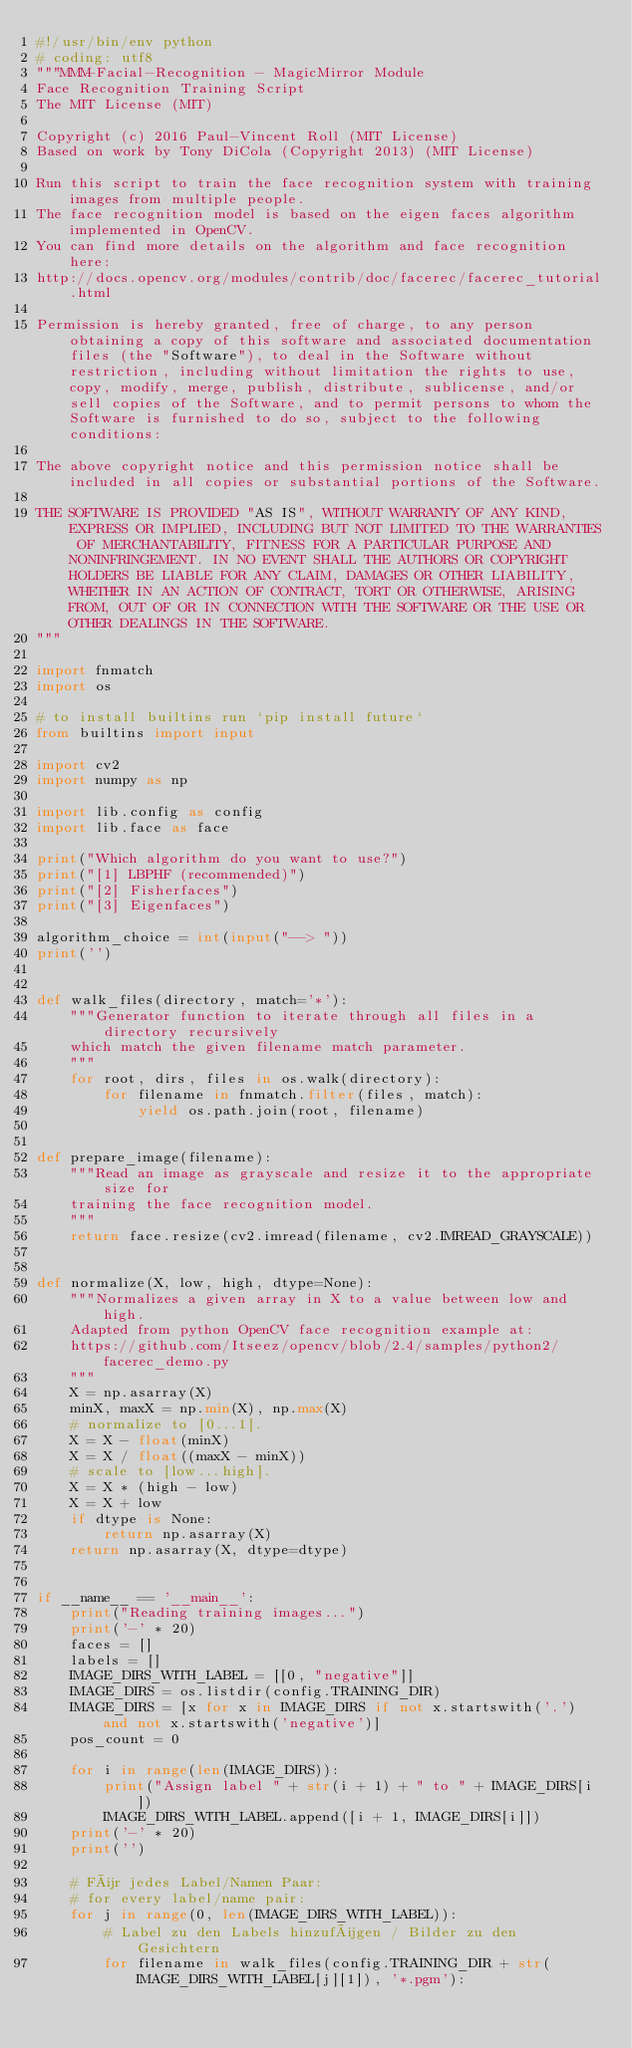Convert code to text. <code><loc_0><loc_0><loc_500><loc_500><_Python_>#!/usr/bin/env python
# coding: utf8
"""MMM-Facial-Recognition - MagicMirror Module
Face Recognition Training Script
The MIT License (MIT)

Copyright (c) 2016 Paul-Vincent Roll (MIT License)
Based on work by Tony DiCola (Copyright 2013) (MIT License)

Run this script to train the face recognition system with training images from multiple people.
The face recognition model is based on the eigen faces algorithm implemented in OpenCV.
You can find more details on the algorithm and face recognition here:
http://docs.opencv.org/modules/contrib/doc/facerec/facerec_tutorial.html

Permission is hereby granted, free of charge, to any person obtaining a copy of this software and associated documentation files (the "Software"), to deal in the Software without restriction, including without limitation the rights to use, copy, modify, merge, publish, distribute, sublicense, and/or sell copies of the Software, and to permit persons to whom the Software is furnished to do so, subject to the following conditions:

The above copyright notice and this permission notice shall be included in all copies or substantial portions of the Software.

THE SOFTWARE IS PROVIDED "AS IS", WITHOUT WARRANTY OF ANY KIND, EXPRESS OR IMPLIED, INCLUDING BUT NOT LIMITED TO THE WARRANTIES OF MERCHANTABILITY, FITNESS FOR A PARTICULAR PURPOSE AND NONINFRINGEMENT. IN NO EVENT SHALL THE AUTHORS OR COPYRIGHT HOLDERS BE LIABLE FOR ANY CLAIM, DAMAGES OR OTHER LIABILITY, WHETHER IN AN ACTION OF CONTRACT, TORT OR OTHERWISE, ARISING FROM, OUT OF OR IN CONNECTION WITH THE SOFTWARE OR THE USE OR OTHER DEALINGS IN THE SOFTWARE.
"""

import fnmatch
import os

# to install builtins run `pip install future` 
from builtins import input

import cv2
import numpy as np

import lib.config as config
import lib.face as face

print("Which algorithm do you want to use?")
print("[1] LBPHF (recommended)")
print("[2] Fisherfaces")
print("[3] Eigenfaces")

algorithm_choice = int(input("--> "))
print('')


def walk_files(directory, match='*'):
    """Generator function to iterate through all files in a directory recursively
    which match the given filename match parameter.
    """
    for root, dirs, files in os.walk(directory):
        for filename in fnmatch.filter(files, match):
            yield os.path.join(root, filename)


def prepare_image(filename):
    """Read an image as grayscale and resize it to the appropriate size for
    training the face recognition model.
    """
    return face.resize(cv2.imread(filename, cv2.IMREAD_GRAYSCALE))


def normalize(X, low, high, dtype=None):
    """Normalizes a given array in X to a value between low and high.
    Adapted from python OpenCV face recognition example at:
    https://github.com/Itseez/opencv/blob/2.4/samples/python2/facerec_demo.py
    """
    X = np.asarray(X)
    minX, maxX = np.min(X), np.max(X)
    # normalize to [0...1].
    X = X - float(minX)
    X = X / float((maxX - minX))
    # scale to [low...high].
    X = X * (high - low)
    X = X + low
    if dtype is None:
        return np.asarray(X)
    return np.asarray(X, dtype=dtype)


if __name__ == '__main__':
    print("Reading training images...")
    print('-' * 20)
    faces = []
    labels = []
    IMAGE_DIRS_WITH_LABEL = [[0, "negative"]]
    IMAGE_DIRS = os.listdir(config.TRAINING_DIR)
    IMAGE_DIRS = [x for x in IMAGE_DIRS if not x.startswith('.') and not x.startswith('negative')]
    pos_count = 0

    for i in range(len(IMAGE_DIRS)):
        print("Assign label " + str(i + 1) + " to " + IMAGE_DIRS[i])
        IMAGE_DIRS_WITH_LABEL.append([i + 1, IMAGE_DIRS[i]])
    print('-' * 20)
    print('')

    # Für jedes Label/Namen Paar:
    # for every label/name pair:
    for j in range(0, len(IMAGE_DIRS_WITH_LABEL)):
        # Label zu den Labels hinzufügen / Bilder zu den Gesichtern
        for filename in walk_files(config.TRAINING_DIR + str(IMAGE_DIRS_WITH_LABEL[j][1]), '*.pgm'):</code> 